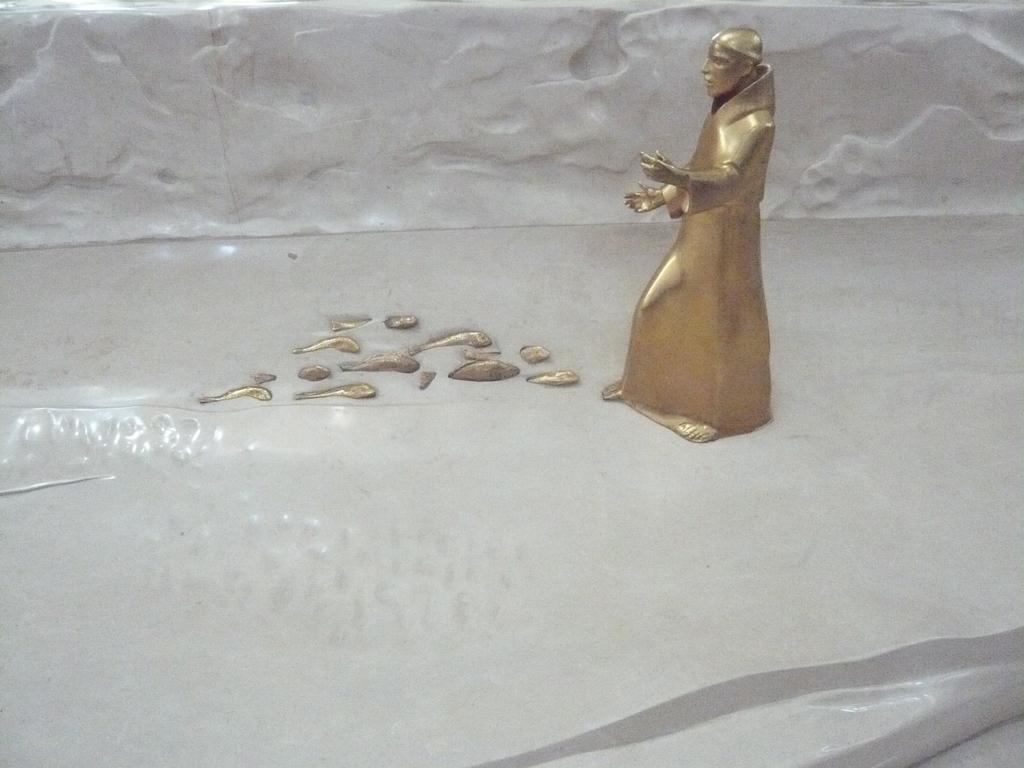What is the main subject of the image? There is a metal sculpture of a person in the image. Can you describe the material used for the sculpture? The sculpture is made of metal. What is the shape or form of the sculpture? The sculpture is in the shape of a person. What type of pancake is being served in the park near the sculpture? There is no information about a park or pancakes in the image, as it only features a metal sculpture of a person. 